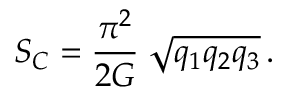Convert formula to latex. <formula><loc_0><loc_0><loc_500><loc_500>S _ { C } = \frac { \pi ^ { 2 } } { 2 G } \, \sqrt { q _ { 1 } q _ { 2 } q _ { 3 } } \, .</formula> 